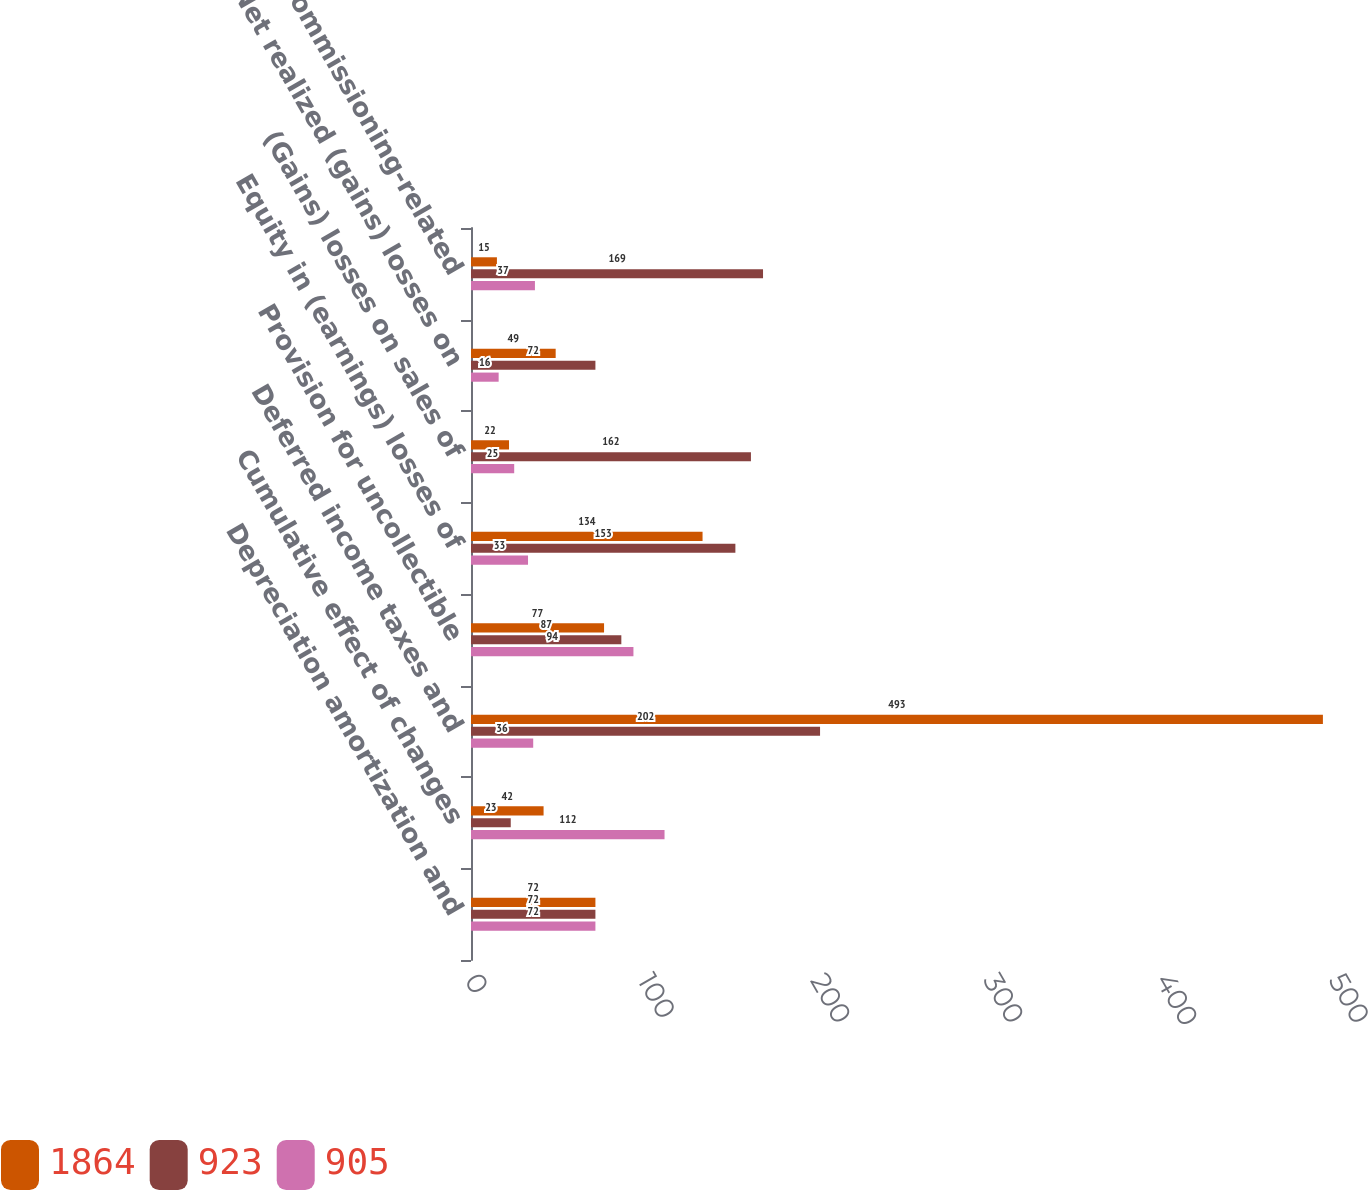Convert chart. <chart><loc_0><loc_0><loc_500><loc_500><stacked_bar_chart><ecel><fcel>Depreciation amortization and<fcel>Cumulative effect of changes<fcel>Deferred income taxes and<fcel>Provision for uncollectible<fcel>Equity in (earnings) losses of<fcel>(Gains) losses on sales of<fcel>Net realized (gains) losses on<fcel>Other decommissioning-related<nl><fcel>1864<fcel>72<fcel>42<fcel>493<fcel>77<fcel>134<fcel>22<fcel>49<fcel>15<nl><fcel>923<fcel>72<fcel>23<fcel>202<fcel>87<fcel>153<fcel>162<fcel>72<fcel>169<nl><fcel>905<fcel>72<fcel>112<fcel>36<fcel>94<fcel>33<fcel>25<fcel>16<fcel>37<nl></chart> 